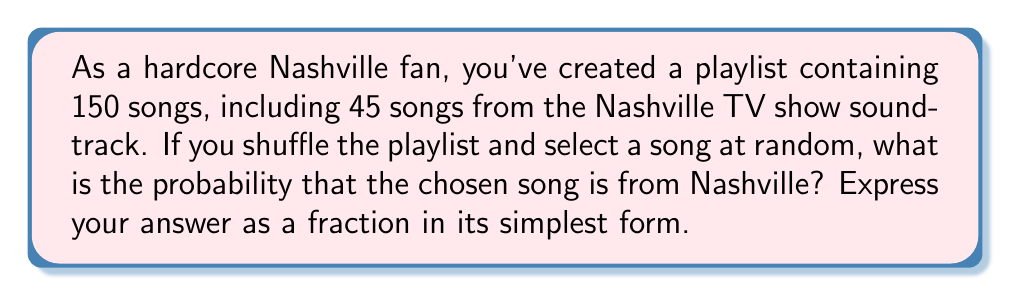Provide a solution to this math problem. To solve this problem, we need to use the basic concept of probability:

$$ \text{Probability} = \frac{\text{Number of favorable outcomes}}{\text{Total number of possible outcomes}} $$

In this case:
- The number of favorable outcomes is the number of Nashville songs: 45
- The total number of possible outcomes is the total number of songs in the playlist: 150

So, we can calculate the probability as follows:

$$ P(\text{Nashville song}) = \frac{45}{150} $$

To simplify this fraction, we need to find the greatest common divisor (GCD) of 45 and 150:

$$ GCD(45, 150) = 15 $$

Now, we can divide both the numerator and denominator by 15:

$$ \frac{45 \div 15}{150 \div 15} = \frac{3}{10} $$

Therefore, the simplified probability is $\frac{3}{10}$.
Answer: $\frac{3}{10}$ 